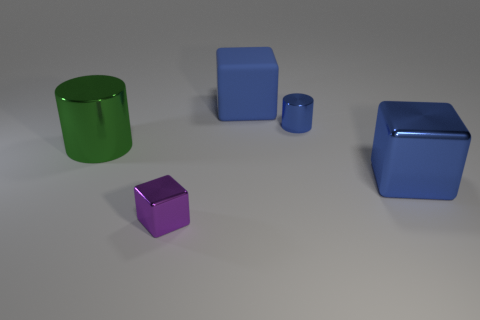Are there the same number of small purple cubes that are right of the large blue matte cube and large objects that are left of the purple metal block?
Ensure brevity in your answer.  No. There is a blue thing in front of the green cylinder; is there a shiny thing in front of it?
Your response must be concise. Yes. What shape is the tiny purple thing that is made of the same material as the green object?
Offer a terse response. Cube. Is there any other thing of the same color as the small cylinder?
Your answer should be very brief. Yes. What material is the small object in front of the shiny thing that is behind the big cylinder?
Ensure brevity in your answer.  Metal. Are there any other large objects that have the same shape as the purple object?
Give a very brief answer. Yes. What number of other objects are there of the same shape as the blue rubber thing?
Your answer should be very brief. 2. There is a object that is to the right of the large blue matte thing and in front of the large green metal thing; what shape is it?
Your response must be concise. Cube. There is a cylinder on the left side of the tiny blue metallic cylinder; how big is it?
Offer a very short reply. Large. Is the size of the green metallic cylinder the same as the blue rubber block?
Provide a succinct answer. Yes. 